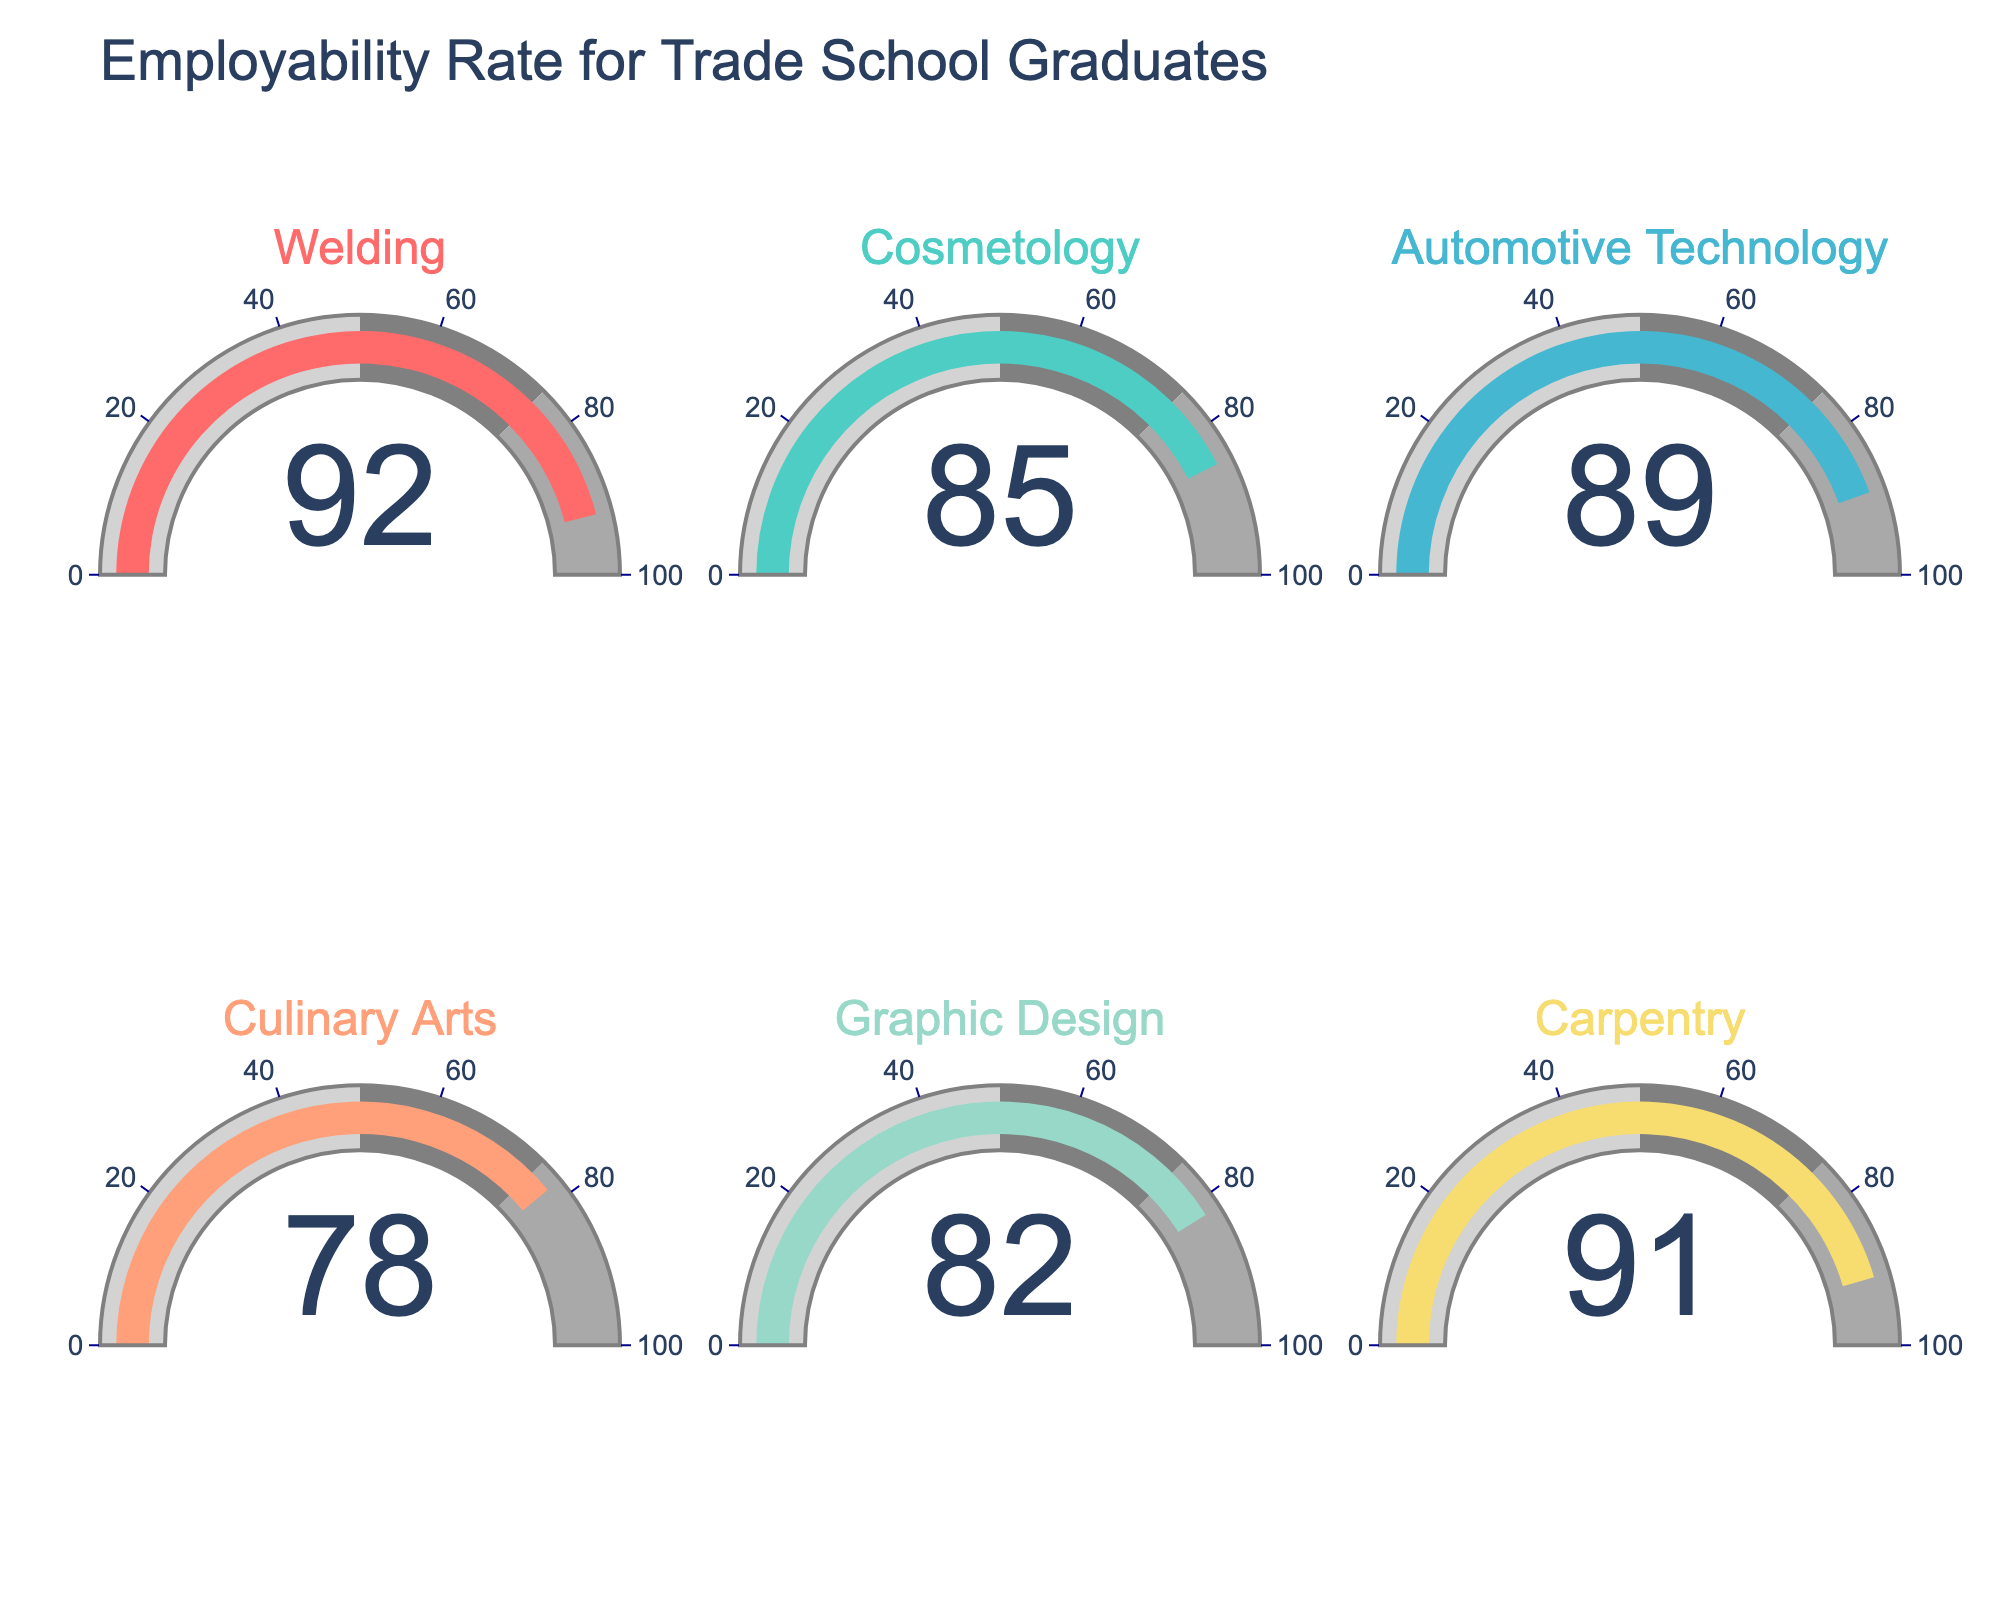Which trade has the highest employability rate? The gauge for Welding displays a value of 92, which is the highest among all trades shown.
Answer: Welding What is the employability rate for Culinary Arts graduates? The gauge for Culinary Arts displays a value of 78.
Answer: 78 How many trades have an employability rate above 90%? The gauges for Welding (92) and Carpentry (91) indicate values above 90%.
Answer: 2 Which trade has a lower employability rate: Cosmetology or Graphic Design? The gauge for Cosmetology displays a value of 85, while the gauge for Graphic Design displays 82. Since 82 is lower than 85, Graphic Design has a lower employability rate.
Answer: Graphic Design What is the average employability rate for all the trades? The employability rates are 92, 85, 89, 78, 82, 91. Summing these gives 517 and there are 6 trades, so the average is 517/6 = 86.17.
Answer: 86.17 Which trade shows a higher employability rate, Automotive Technology or Culinary Arts? The gauge for Automotive Technology displays a value of 89, while the gauge for Culinary Arts shows 78. Since 89 is higher than 78, Automotive Technology has the higher employability rate.
Answer: Automotive Technology What is the range of employability rates displayed on the chart? The highest employability rate displayed is 92 (Welding) and the lowest is 78 (Culinary Arts). The range is 92 - 78 = 14.
Answer: 14 How does the employability rate of Carpentry compare to that of Automotive Technology? The gauge for Carpentry shows a rate of 91, while Automotive Technology is at 89. Since 91 is greater than 89, Carpentry has a higher employability rate.
Answer: Carpentry 